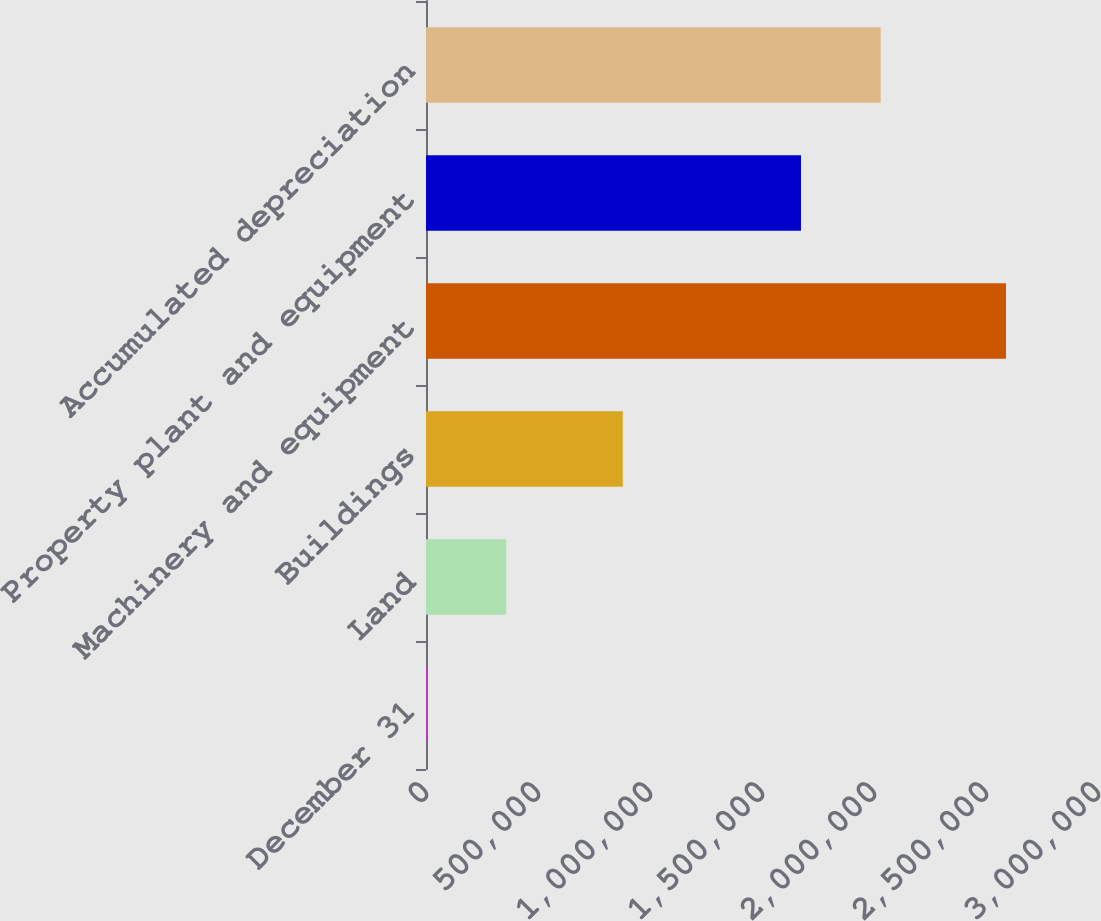Convert chart to OTSL. <chart><loc_0><loc_0><loc_500><loc_500><bar_chart><fcel>December 31<fcel>Land<fcel>Buildings<fcel>Machinery and equipment<fcel>Property plant and equipment<fcel>Accumulated depreciation<nl><fcel>2012<fcel>357873<fcel>878527<fcel>2.58918e+06<fcel>1.67407e+06<fcel>2.02993e+06<nl></chart> 